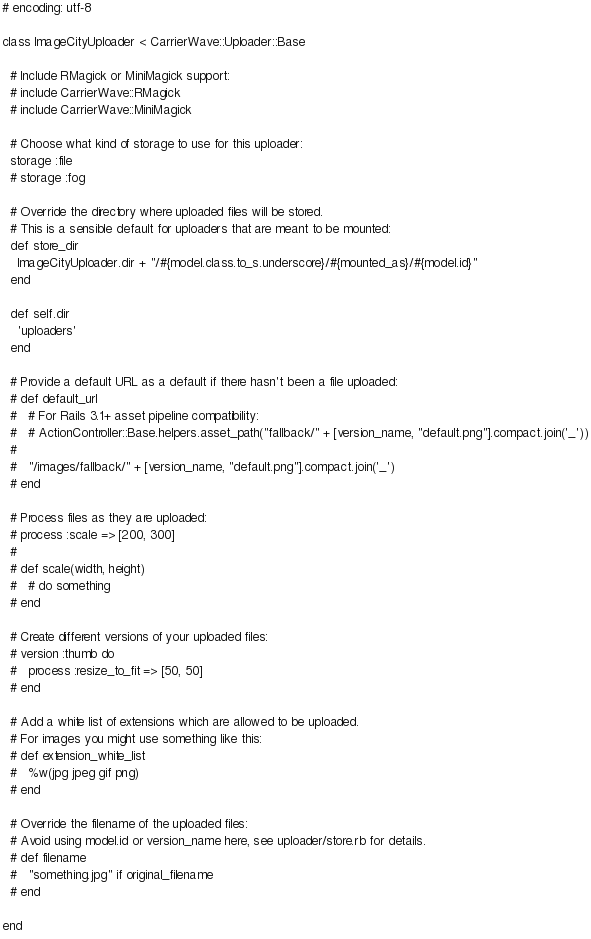<code> <loc_0><loc_0><loc_500><loc_500><_Ruby_># encoding: utf-8

class ImageCityUploader < CarrierWave::Uploader::Base

  # Include RMagick or MiniMagick support:
  # include CarrierWave::RMagick
  # include CarrierWave::MiniMagick

  # Choose what kind of storage to use for this uploader:
  storage :file
  # storage :fog

  # Override the directory where uploaded files will be stored.
  # This is a sensible default for uploaders that are meant to be mounted:
  def store_dir
    ImageCityUploader.dir + "/#{model.class.to_s.underscore}/#{mounted_as}/#{model.id}"
  end

  def self.dir
    'uploaders'
  end

  # Provide a default URL as a default if there hasn't been a file uploaded:
  # def default_url
  #   # For Rails 3.1+ asset pipeline compatibility:
  #   # ActionController::Base.helpers.asset_path("fallback/" + [version_name, "default.png"].compact.join('_'))
  #
  #   "/images/fallback/" + [version_name, "default.png"].compact.join('_')
  # end

  # Process files as they are uploaded:
  # process :scale => [200, 300]
  #
  # def scale(width, height)
  #   # do something
  # end

  # Create different versions of your uploaded files:
  # version :thumb do
  #   process :resize_to_fit => [50, 50]
  # end

  # Add a white list of extensions which are allowed to be uploaded.
  # For images you might use something like this:
  # def extension_white_list
  #   %w(jpg jpeg gif png)
  # end

  # Override the filename of the uploaded files:
  # Avoid using model.id or version_name here, see uploader/store.rb for details.
  # def filename
  #   "something.jpg" if original_filename
  # end

end
</code> 